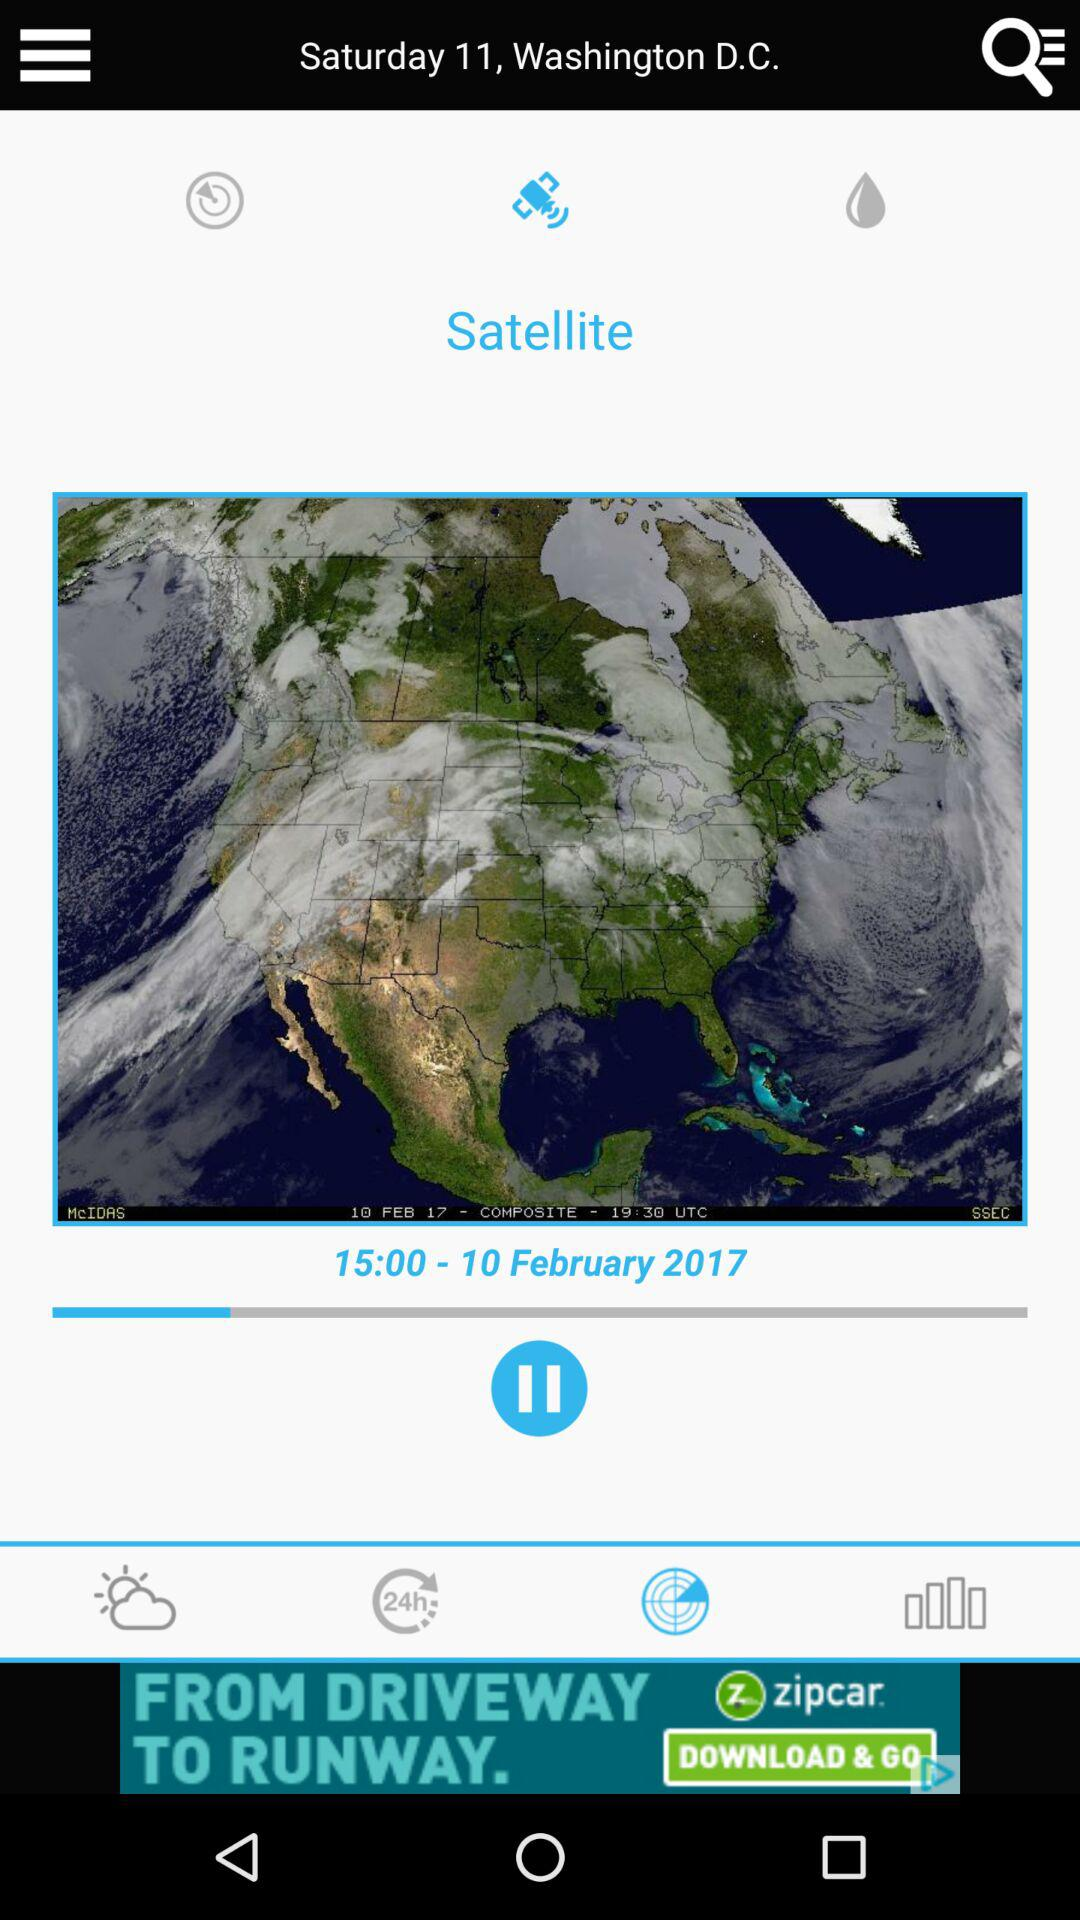In what year was the image taken by the satellite? The image was taken by the satellite in 2017. 